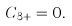<formula> <loc_0><loc_0><loc_500><loc_500>C _ { 3 + } = 0 .</formula> 